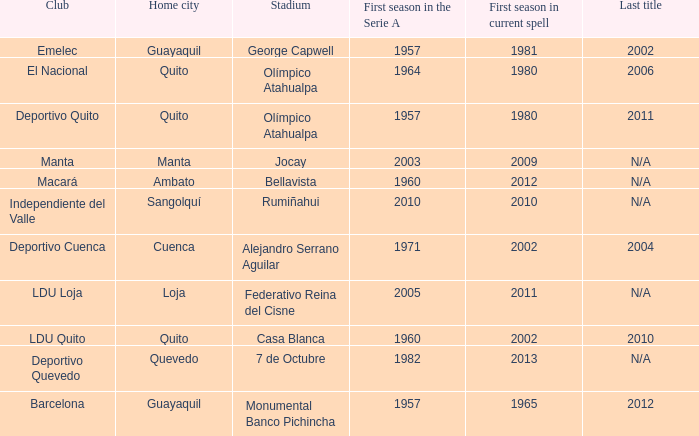Name the last title for 2012 N/A. 